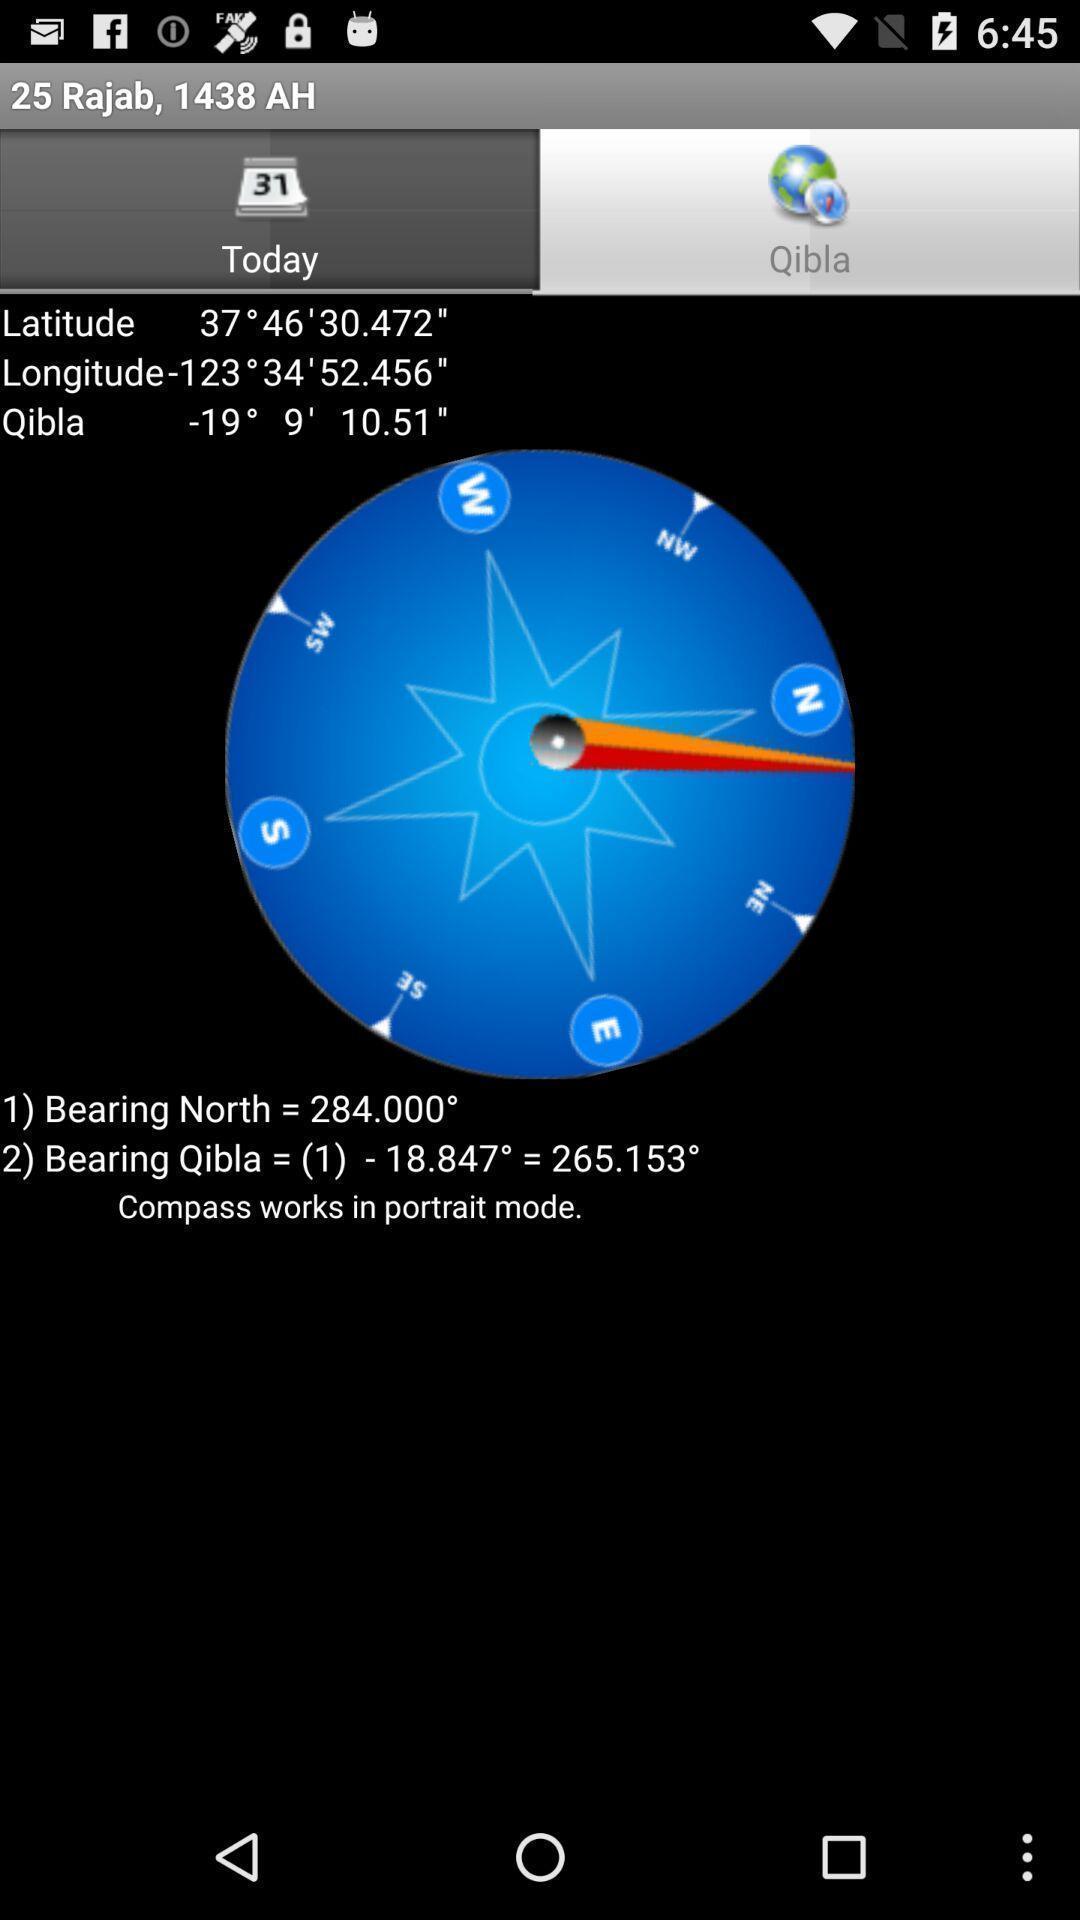Provide a detailed account of this screenshot. Page showing different directions on app. 